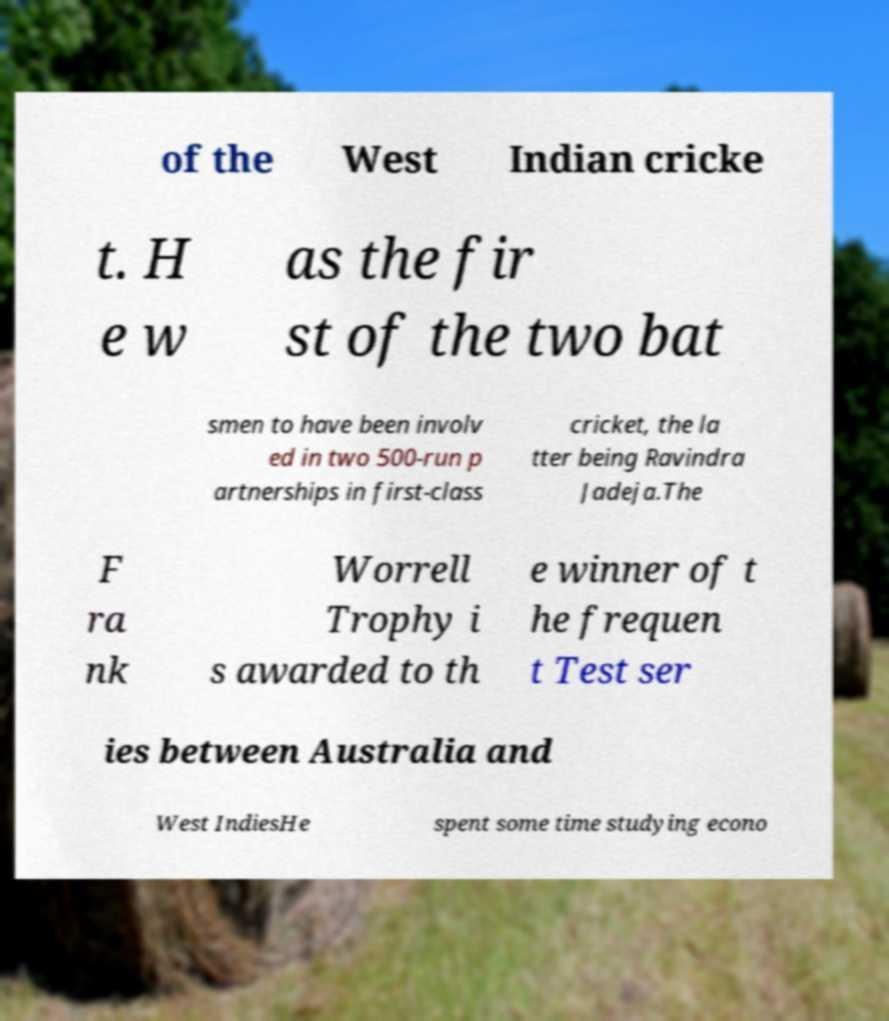Could you assist in decoding the text presented in this image and type it out clearly? of the West Indian cricke t. H e w as the fir st of the two bat smen to have been involv ed in two 500-run p artnerships in first-class cricket, the la tter being Ravindra Jadeja.The F ra nk Worrell Trophy i s awarded to th e winner of t he frequen t Test ser ies between Australia and West IndiesHe spent some time studying econo 